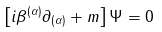<formula> <loc_0><loc_0><loc_500><loc_500>\left [ i \beta ^ { ( \alpha ) } \partial _ { ( \alpha ) } + m \right ] \Psi = 0</formula> 